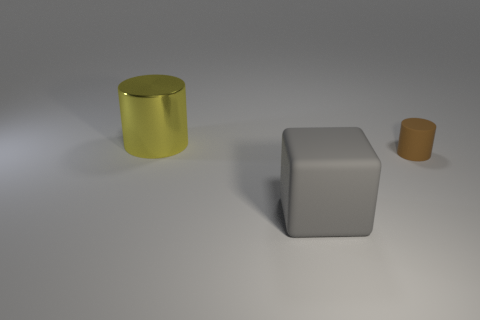Are the large object behind the tiny brown cylinder and the gray block made of the same material?
Ensure brevity in your answer.  No. Are there an equal number of small brown cylinders in front of the big rubber thing and brown cylinders behind the yellow metallic thing?
Your response must be concise. Yes. There is a big object on the right side of the shiny cylinder; how many big yellow objects are left of it?
Your response must be concise. 1. Does the cylinder on the right side of the big cylinder have the same color as the rubber thing that is left of the small rubber cylinder?
Your answer should be compact. No. There is a yellow cylinder that is the same size as the block; what is its material?
Give a very brief answer. Metal. The big thing in front of the cylinder right of the cylinder that is behind the tiny thing is what shape?
Keep it short and to the point. Cube. What shape is the other object that is the same size as the yellow thing?
Give a very brief answer. Cube. How many gray things are in front of the cylinder that is to the left of the thing that is in front of the brown matte thing?
Provide a short and direct response. 1. Is the number of large gray rubber things that are behind the yellow cylinder greater than the number of gray cubes on the left side of the gray matte object?
Give a very brief answer. No. What number of other big gray objects are the same shape as the big gray matte object?
Offer a very short reply. 0. 